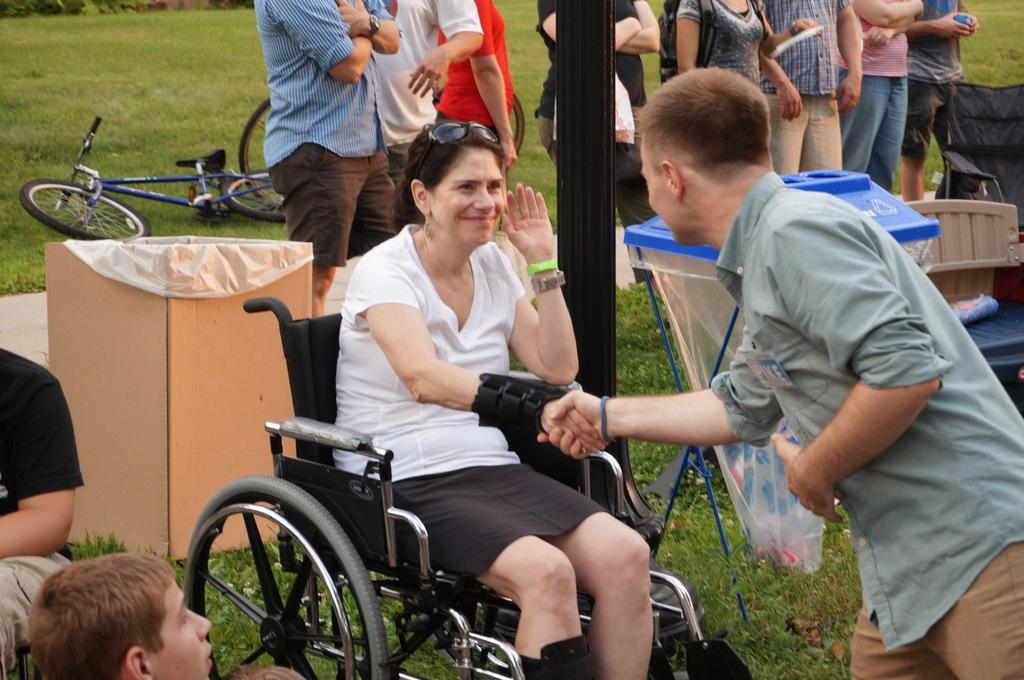Describe this image in one or two sentences. On the left side, there is a person in black color t-shirt sitting near a boy. Beside this boy, there is a woman in white color t-shirt sitting on a wheel chair and is shaking hand with a person who is in gray color shirt and is slightly bending on the grass on the ground. In the background, there are persons in different color dresses standing near a dustbin, box and other objects and there is a bicycle fallen on the grass on the ground. 